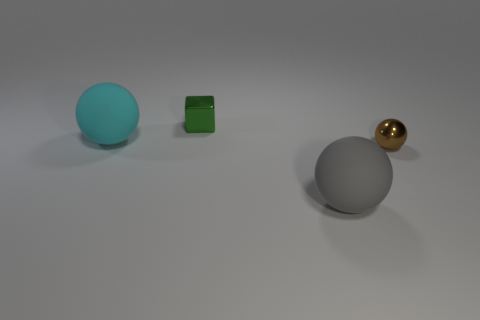Add 1 tiny brown objects. How many objects exist? 5 Subtract all blocks. How many objects are left? 3 Subtract all small brown shiny balls. Subtract all cyan objects. How many objects are left? 2 Add 2 cyan rubber things. How many cyan rubber things are left? 3 Add 1 rubber things. How many rubber things exist? 3 Subtract 0 gray blocks. How many objects are left? 4 